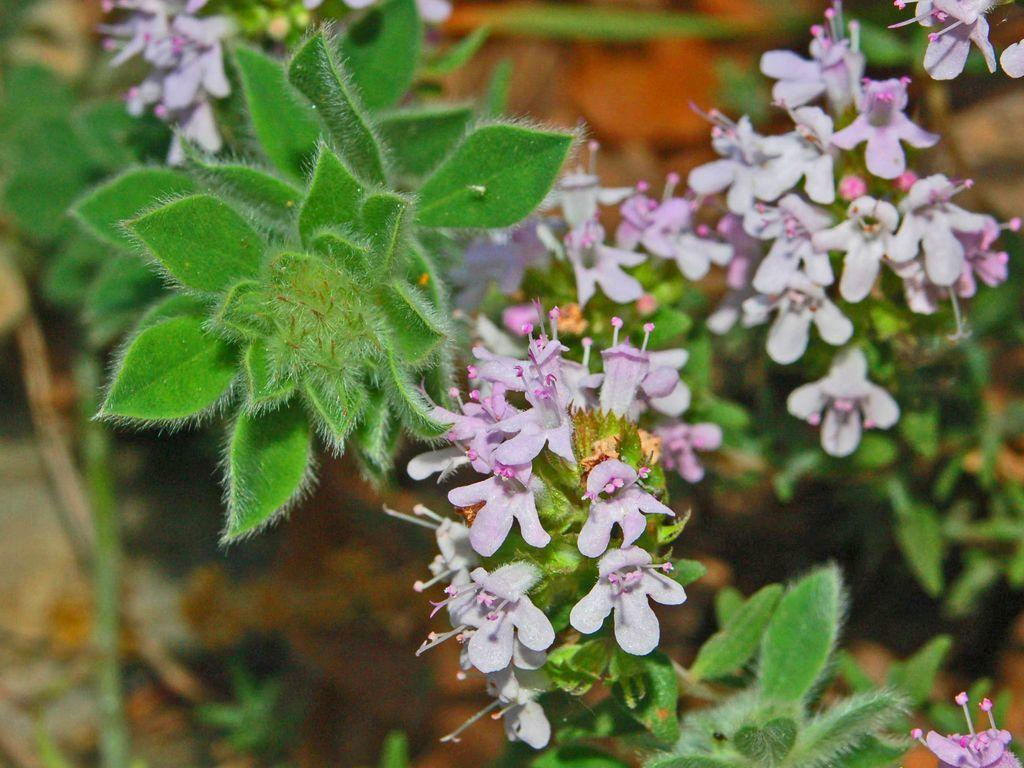What types of living organisms can be seen in the image? Plants and flowers are visible in the image. Can you describe the background of the image? The background of the image is blurred. What type of airplane can be seen flying over the flowers in the image? There is no airplane present in the image; it only features plants and flowers. How does the anger of the plants and flowers affect the image? There is no indication of anger in the image, as plants and flowers do not have emotions. 